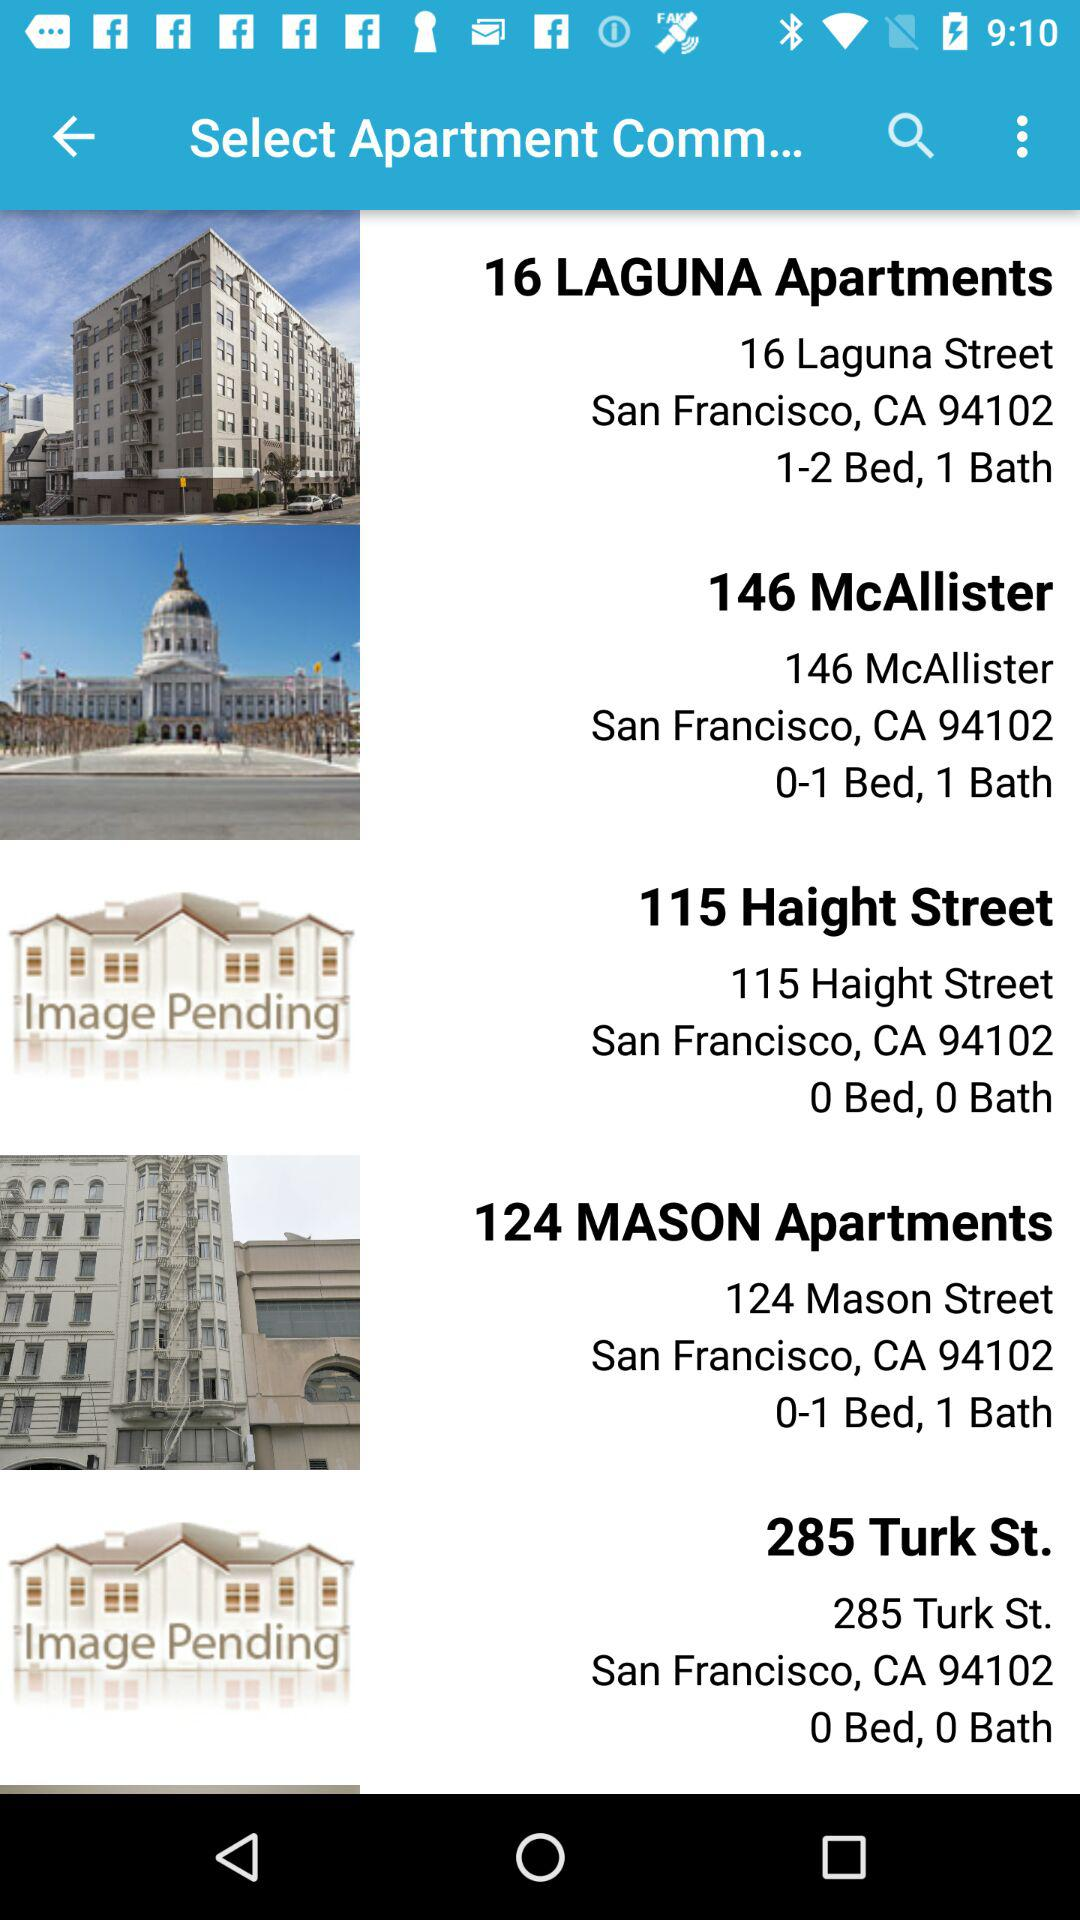How many beds are there in 124 Mason Apartments? There is 1 bed in 124 Mason Apartments. 